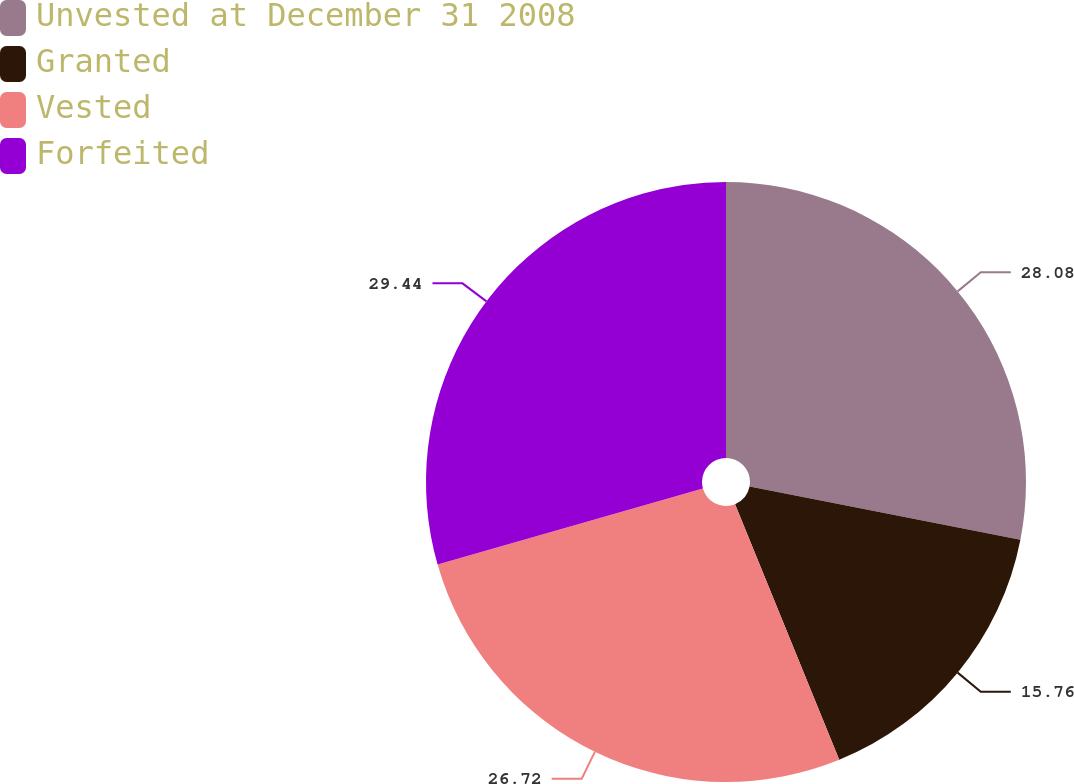<chart> <loc_0><loc_0><loc_500><loc_500><pie_chart><fcel>Unvested at December 31 2008<fcel>Granted<fcel>Vested<fcel>Forfeited<nl><fcel>28.08%<fcel>15.76%<fcel>26.72%<fcel>29.44%<nl></chart> 